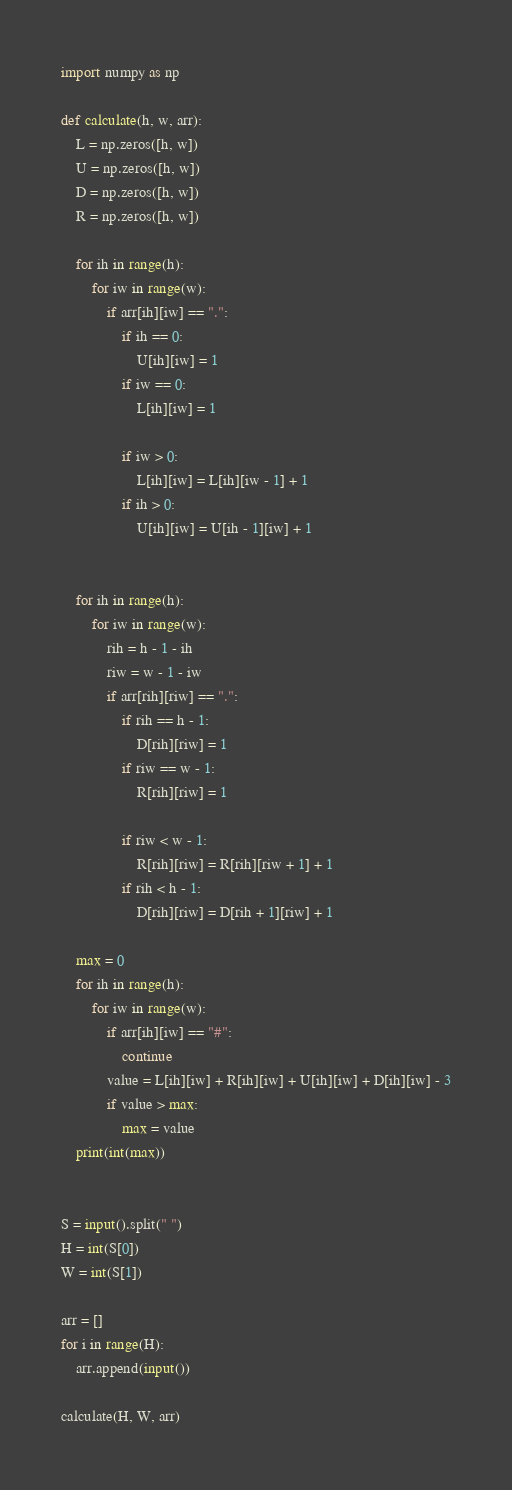<code> <loc_0><loc_0><loc_500><loc_500><_Python_>import numpy as np

def calculate(h, w, arr):
    L = np.zeros([h, w])
    U = np.zeros([h, w])
    D = np.zeros([h, w])
    R = np.zeros([h, w])

    for ih in range(h):
        for iw in range(w):
            if arr[ih][iw] == ".":
                if ih == 0:
                    U[ih][iw] = 1
                if iw == 0:
                    L[ih][iw] = 1

                if iw > 0:
                    L[ih][iw] = L[ih][iw - 1] + 1
                if ih > 0:
                    U[ih][iw] = U[ih - 1][iw] + 1


    for ih in range(h):
        for iw in range(w):
            rih = h - 1 - ih
            riw = w - 1 - iw
            if arr[rih][riw] == ".":
                if rih == h - 1:
                    D[rih][riw] = 1
                if riw == w - 1:
                    R[rih][riw] = 1

                if riw < w - 1:
                    R[rih][riw] = R[rih][riw + 1] + 1
                if rih < h - 1:
                    D[rih][riw] = D[rih + 1][riw] + 1

    max = 0
    for ih in range(h):
        for iw in range(w):
            if arr[ih][iw] == "#":
                continue
            value = L[ih][iw] + R[ih][iw] + U[ih][iw] + D[ih][iw] - 3
            if value > max:
                max = value
    print(int(max))


S = input().split(" ")
H = int(S[0])
W = int(S[1])

arr = []
for i in range(H):
    arr.append(input())

calculate(H, W, arr)
</code> 